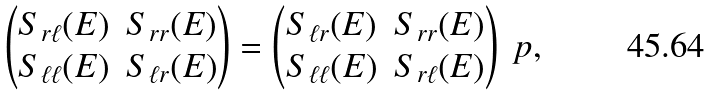<formula> <loc_0><loc_0><loc_500><loc_500>\begin{pmatrix} S _ { r \ell } ( E ) & S _ { r r } ( E ) \\ S _ { \ell \ell } ( E ) & S _ { \ell r } ( E ) \end{pmatrix} = \begin{pmatrix} S _ { \ell r } ( E ) & S _ { r r } ( E ) \\ S _ { \ell \ell } ( E ) & S _ { r \ell } ( E ) \end{pmatrix} \ p ,</formula> 